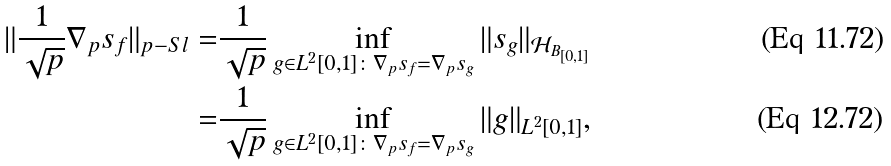<formula> <loc_0><loc_0><loc_500><loc_500>\| \frac { 1 } { \sqrt { p } } \nabla _ { p } s _ { f } \| _ { p - S l } = & \frac { 1 } { \sqrt { p } } \inf _ { g \in L ^ { 2 } [ 0 , 1 ] \colon \nabla _ { p } s _ { f } = \nabla _ { p } s _ { g } } \| s _ { g } \| _ { \mathcal { H } _ { B _ { [ 0 , 1 ] } } } \\ = & \frac { 1 } { \sqrt { p } } \inf _ { g \in L ^ { 2 } [ 0 , 1 ] \colon \nabla _ { p } s _ { f } = \nabla _ { p } s _ { g } } \| g \| _ { L ^ { 2 } [ 0 , 1 ] } ,</formula> 